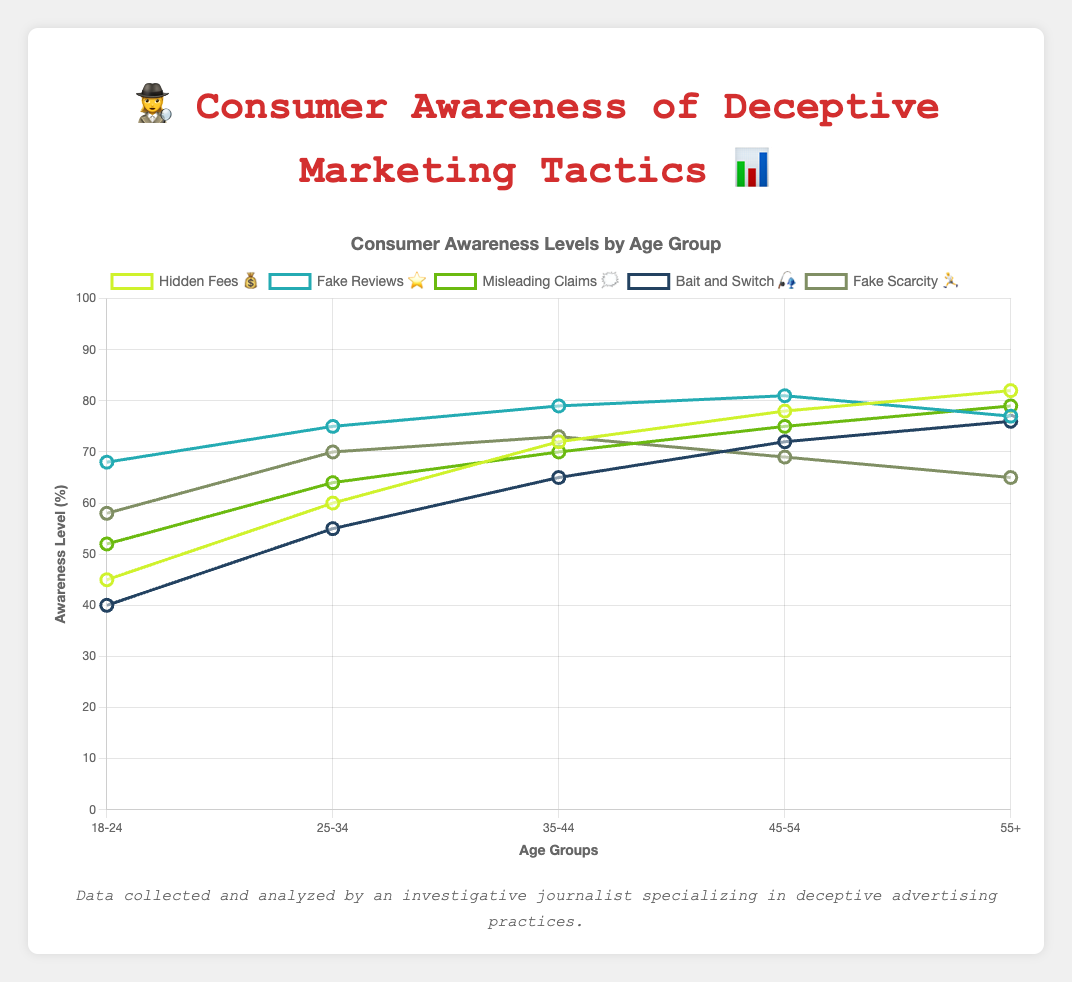what is the age group with the highest awareness of Hidden Fees 💰? By looking at the data points in the chart for Hidden Fees 💰, we see that the awareness level is highest for the 55+ age group.
Answer: 55+ Which deceptive marketing tactic has the lowest awareness level among the 18-24 age group? By examining the awareness levels for the 18-24 age group across all deceptive marketing tactics, Bait and Switch 🎣 has the lowest awareness level at 40%.
Answer: Bait and Switch 🎣 How does the awareness of Fake Reviews ⭐ compare between the 35-44 and 55+ age groups? From the data, the awareness levels for Fake Reviews ⭐ are 79% for the 35-44 age group and 77% for the 55+ age group. 79% is greater than 77%.
Answer: 35-44 > 55+ What is the average awareness level of Misleading Claims 🗯️ across all age groups? Adding the awareness levels for Misleading Claims 🗯️: (52 + 64 + 70 + 75 + 79) and dividing by the number of age groups (5), we get: (52 + 64 + 70 + 75 + 79) / 5 = 68%
Answer: 68% Is the awareness of Fake Scarcity 🏃 higher or lower for the 45-54 age group compared to the 55+ age group? Comparing the awareness levels for Fake Scarcity 🏃, the value is 69% for the 45-54 age group and 65% for the 55+ age group. So, 69% is higher than 65%.
Answer: Higher Between the age groups of 18-24 and 25-34, which one has a greater awareness of Hidden Fees 💰 and by how much? From the data, the awareness levels for Hidden Fees 💰 are 45% for 18-24 and 60% for 25-34. The difference is 60% - 45% = 15%.
Answer: 25-34, by 15% What trend can you observe regarding the awareness of Hidden Fees 💰 across the age groups? The awareness levels for Hidden Fees 💰 generally increase as the age group increases, starting from 45% for 18-24, and reaching 82% for the 55+ age group.
Answer: Increasing trend Which tactic shows a decrease in awareness as the age increases from 45-54 to 55+? Looking at all the deceptive tactics, Fake Scarcity 🏃 shows a decrease in awareness from 69% to 65% when moving from the 45-54 age group to the 55+ age group.
Answer: Fake Scarcity 🏃 What is the total combined awareness level of Bait and Switch 🎣 for the age groups of 35-44 and 45-54? Adding the awareness levels for Bait and Switch 🎣 for the 35-44 and 45-54 age groups: 65% + 72% = 137%.
Answer: 137% What is the difference in awareness levels of Misleading Claims 🗯️ between the age groups 18-24 and 55+? The awareness levels for Misleading Claims 🗯️ are 52% for 18-24 and 79% for 55+. The difference is 79% - 52% = 27%.
Answer: 27% 